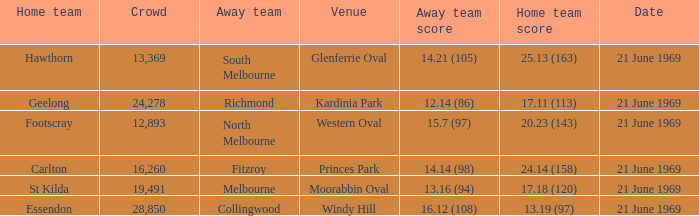When was there a game at Kardinia Park? 21 June 1969. 